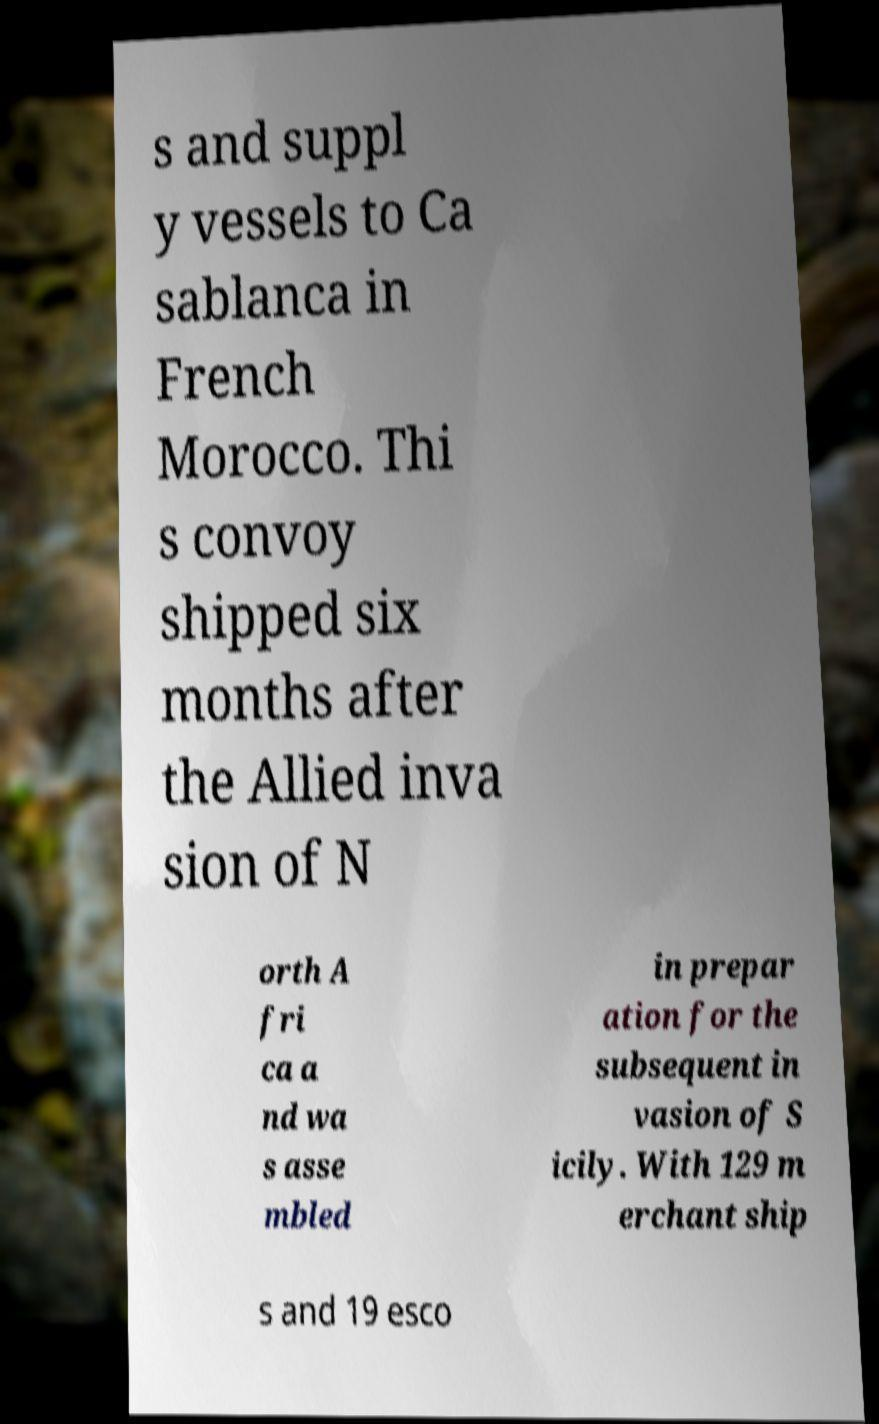Can you read and provide the text displayed in the image?This photo seems to have some interesting text. Can you extract and type it out for me? s and suppl y vessels to Ca sablanca in French Morocco. Thi s convoy shipped six months after the Allied inva sion of N orth A fri ca a nd wa s asse mbled in prepar ation for the subsequent in vasion of S icily. With 129 m erchant ship s and 19 esco 